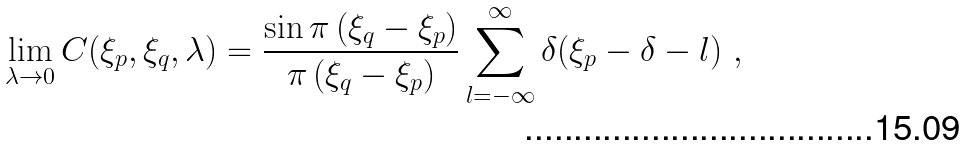Convert formula to latex. <formula><loc_0><loc_0><loc_500><loc_500>\lim _ { \lambda \to 0 } C ( \xi _ { p } , \xi _ { q } , \lambda ) = \frac { \sin \pi \left ( \xi _ { q } - \xi _ { p } \right ) } { \pi \left ( \xi _ { q } - \xi _ { p } \right ) } \sum _ { l = - \infty } ^ { \infty } \delta ( \xi _ { p } - \delta - l ) \ ,</formula> 